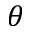Convert formula to latex. <formula><loc_0><loc_0><loc_500><loc_500>\theta</formula> 